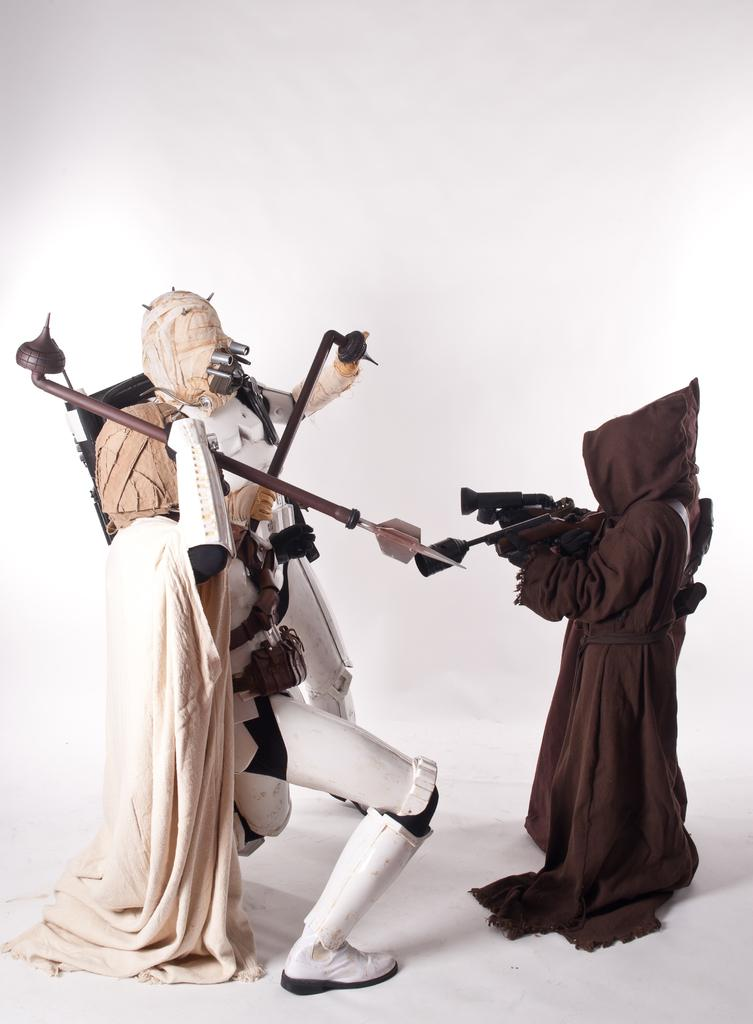What are the people in the image wearing on their faces? The people in the image are wearing masks. What are the people holding in their hands? The people are holding sticks. What color is the background of the image? The background of the image is white. What type of cat can be seen playing with a gun in the image? There is no cat or gun present in the image; it features people wearing masks and holding sticks. What kind of creature is shown interacting with the people in the image? There is no creature shown interacting with the people in the image; only the people wearing masks and holding sticks are present. 